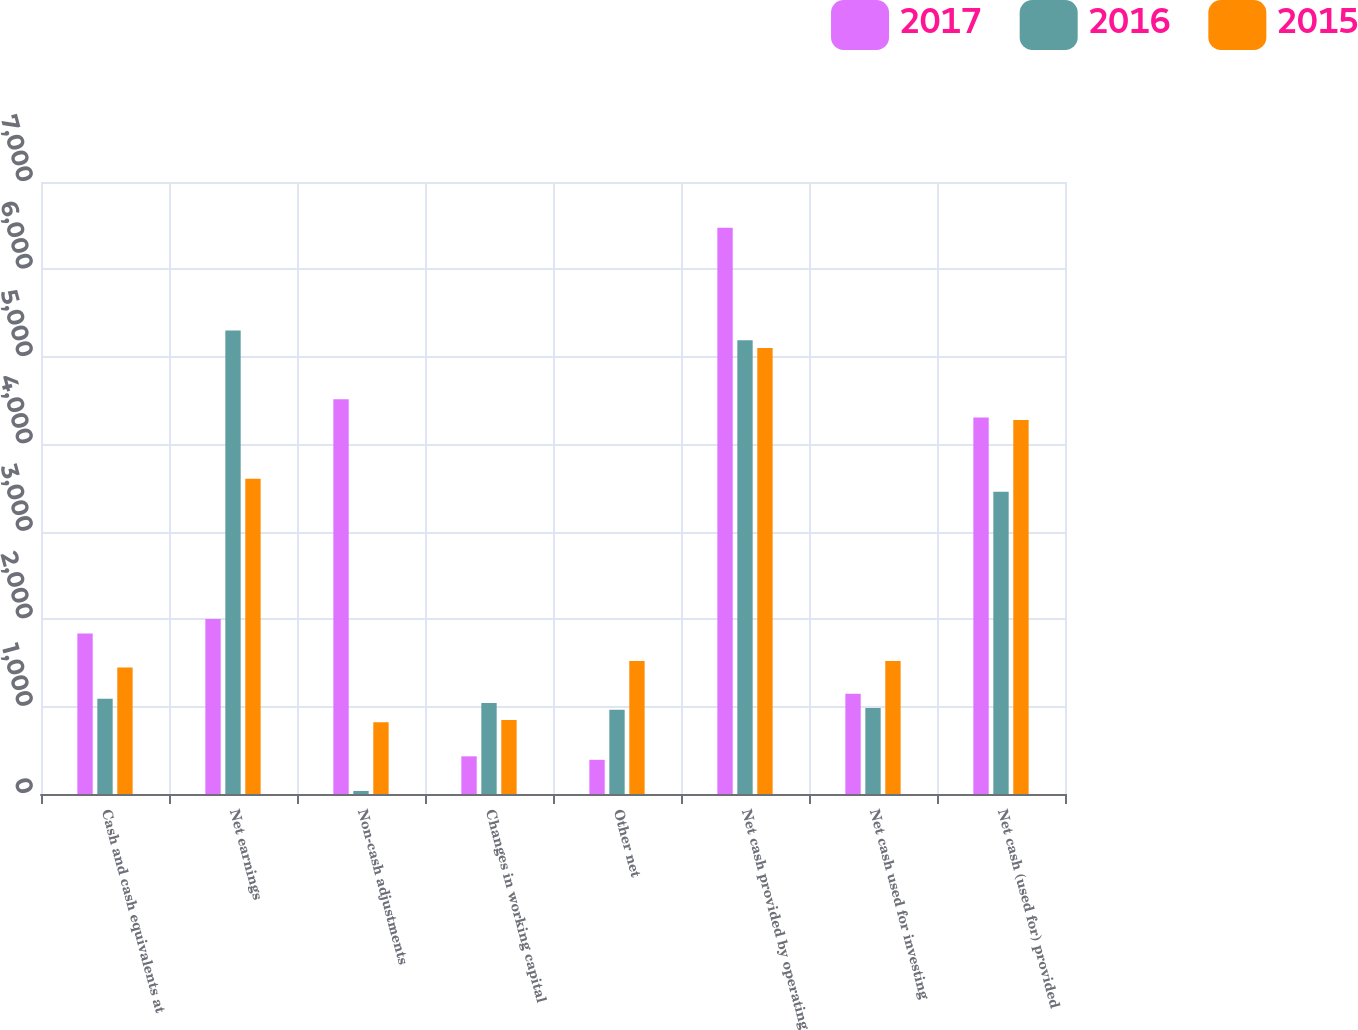Convert chart. <chart><loc_0><loc_0><loc_500><loc_500><stacked_bar_chart><ecel><fcel>Cash and cash equivalents at<fcel>Net earnings<fcel>Non-cash adjustments<fcel>Changes in working capital<fcel>Other net<fcel>Net cash provided by operating<fcel>Net cash used for investing<fcel>Net cash (used for) provided<nl><fcel>2017<fcel>1837<fcel>2002<fcel>4514<fcel>431<fcel>391<fcel>6476<fcel>1147<fcel>4305<nl><fcel>2016<fcel>1090<fcel>5302<fcel>35<fcel>1042<fcel>964<fcel>5189<fcel>985<fcel>3457<nl><fcel>2015<fcel>1446<fcel>3605<fcel>821<fcel>846<fcel>1521<fcel>5101<fcel>1521<fcel>4277<nl></chart> 